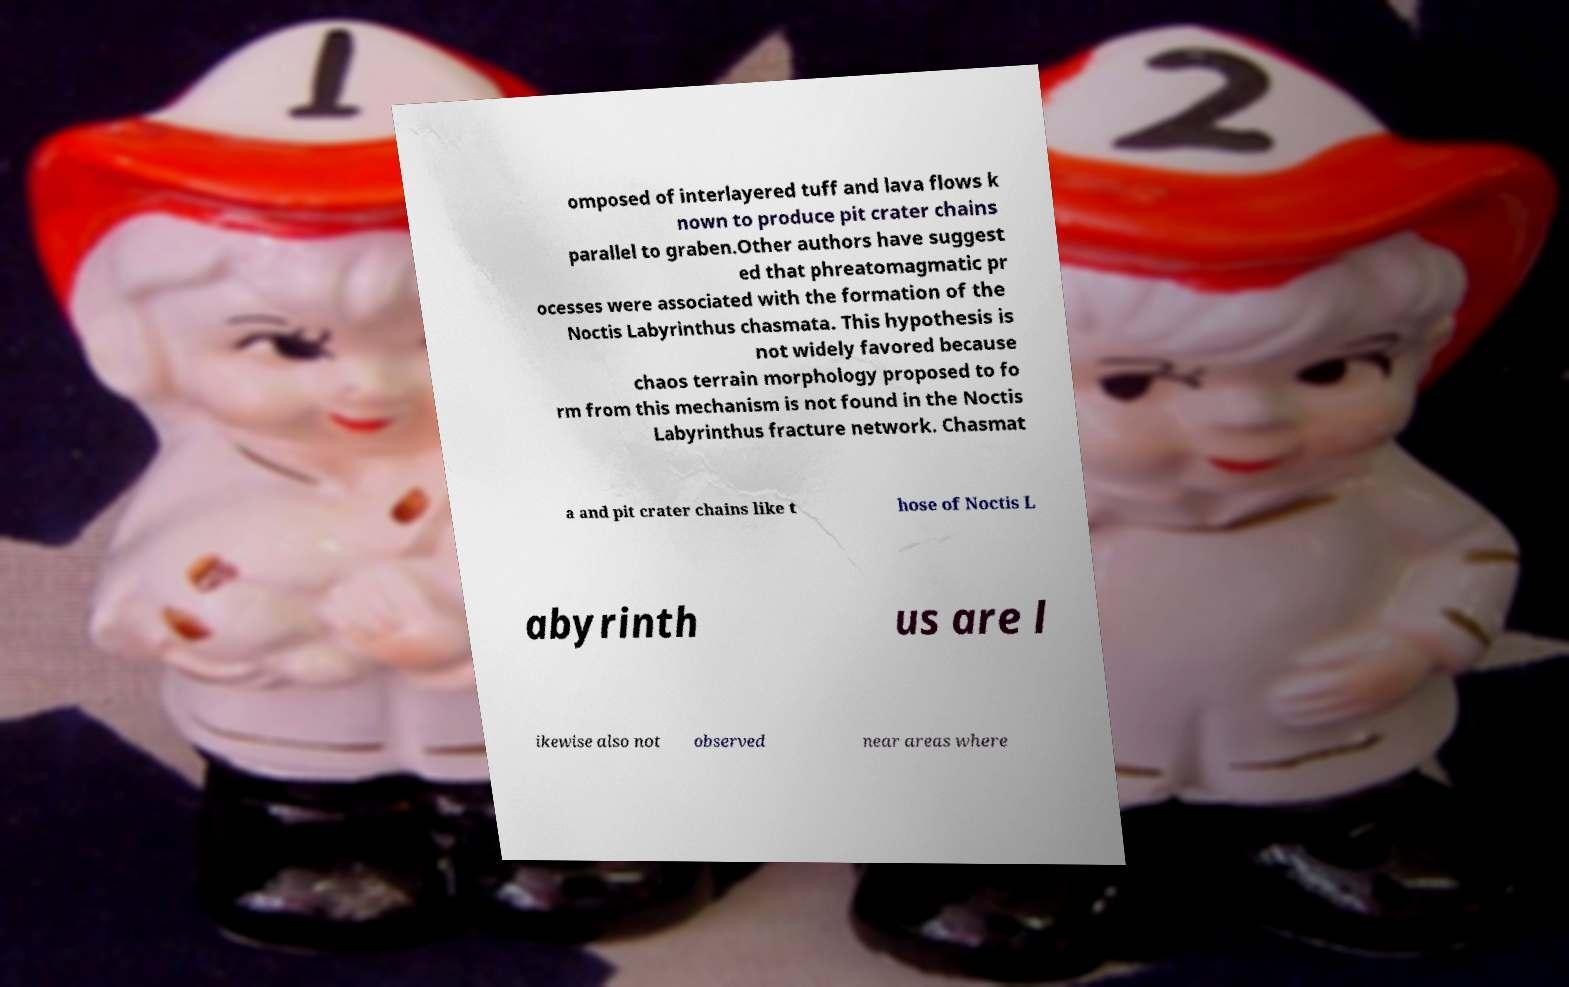Please read and relay the text visible in this image. What does it say? omposed of interlayered tuff and lava flows k nown to produce pit crater chains parallel to graben.Other authors have suggest ed that phreatomagmatic pr ocesses were associated with the formation of the Noctis Labyrinthus chasmata. This hypothesis is not widely favored because chaos terrain morphology proposed to fo rm from this mechanism is not found in the Noctis Labyrinthus fracture network. Chasmat a and pit crater chains like t hose of Noctis L abyrinth us are l ikewise also not observed near areas where 